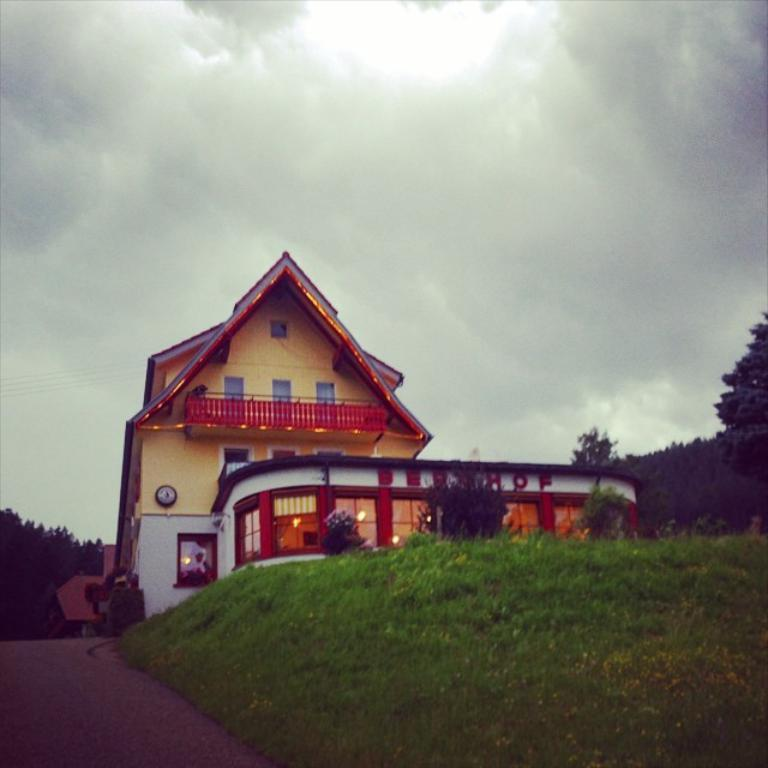What type of structure is visible in the image? There is a building in the image. What other natural elements can be seen in the image? There are trees and grass visible in the image. Are there any artificial light sources in the image? Yes, there are lights in the image. What can be seen in the background of the image? The sky is visible in the background of the image. What arithmetic problem is being solved on the edge of the building in the image? There is no arithmetic problem or any indication of one being solved in the image. 